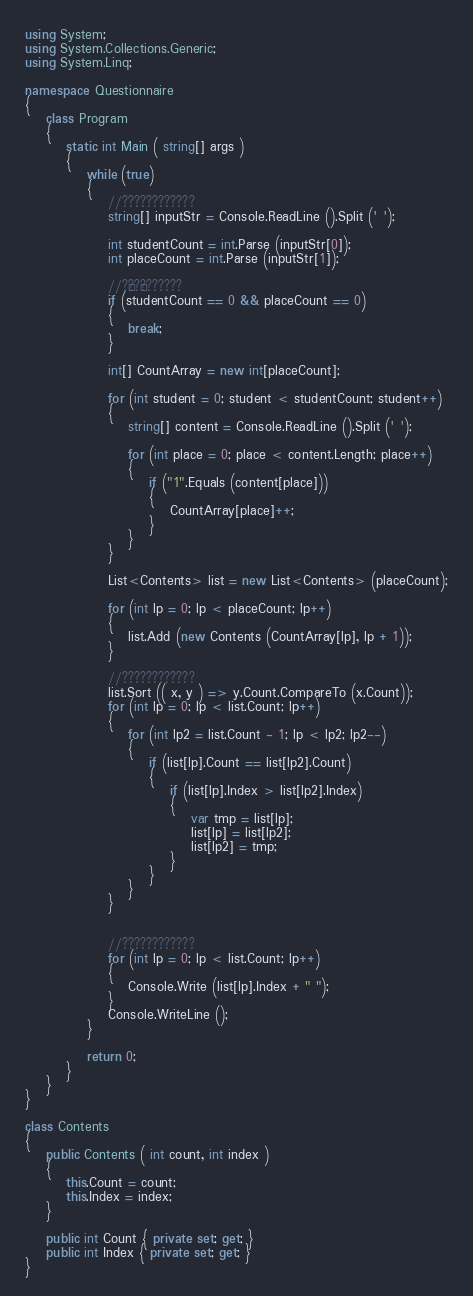<code> <loc_0><loc_0><loc_500><loc_500><_C#_>using System;
using System.Collections.Generic;
using System.Linq;

namespace Questionnaire
{
	class Program
	{
		static int Main ( string[] args )
		{
			while (true)
			{
				//????????????
				string[] inputStr = Console.ReadLine ().Split (' ');

				int studentCount = int.Parse (inputStr[0]);
				int placeCount = int.Parse (inputStr[1]);

				//?¶??¶???????
				if (studentCount == 0 && placeCount == 0)
				{
					break;
				}

				int[] CountArray = new int[placeCount];

				for (int student = 0; student < studentCount; student++)
				{
					string[] content = Console.ReadLine ().Split (' ');

					for (int place = 0; place < content.Length; place++)
					{
						if ("1".Equals (content[place]))
						{
							CountArray[place]++;
						}
					}
				}

				List<Contents> list = new List<Contents> (placeCount);

				for (int lp = 0; lp < placeCount; lp++)
				{
					list.Add (new Contents (CountArray[lp], lp + 1));
				}

				//????????????
				list.Sort (( x, y ) => y.Count.CompareTo (x.Count));
				for (int lp = 0; lp < list.Count; lp++)
				{
					for (int lp2 = list.Count - 1; lp < lp2; lp2--)
					{
						if (list[lp].Count == list[lp2].Count)
						{
							if (list[lp].Index > list[lp2].Index)
							{
								var tmp = list[lp];
								list[lp] = list[lp2];
								list[lp2] = tmp;
							}
						}
					}
				}


				//????????????
				for (int lp = 0; lp < list.Count; lp++)
				{
					Console.Write (list[lp].Index + " ");
				}
				Console.WriteLine ();
			}

			return 0;
		}
	}
}

class Contents
{
	public Contents ( int count, int index )
	{
		this.Count = count;
		this.Index = index;
	}

	public int Count { private set; get; }
	public int Index { private set; get; }
}</code> 